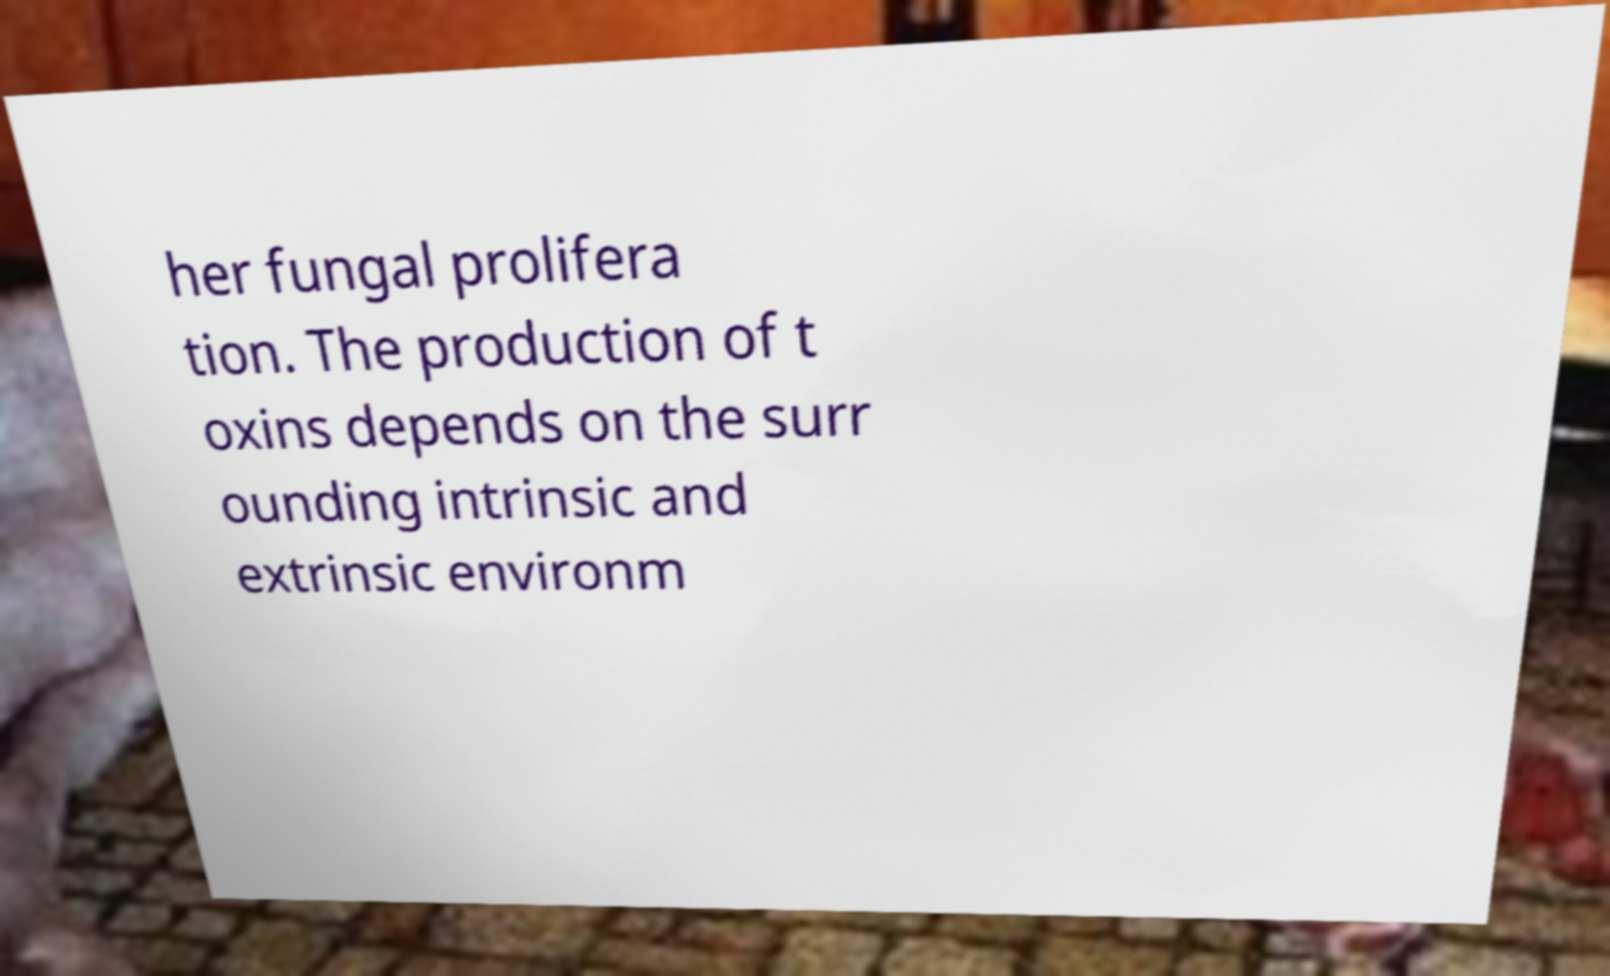What messages or text are displayed in this image? I need them in a readable, typed format. her fungal prolifera tion. The production of t oxins depends on the surr ounding intrinsic and extrinsic environm 